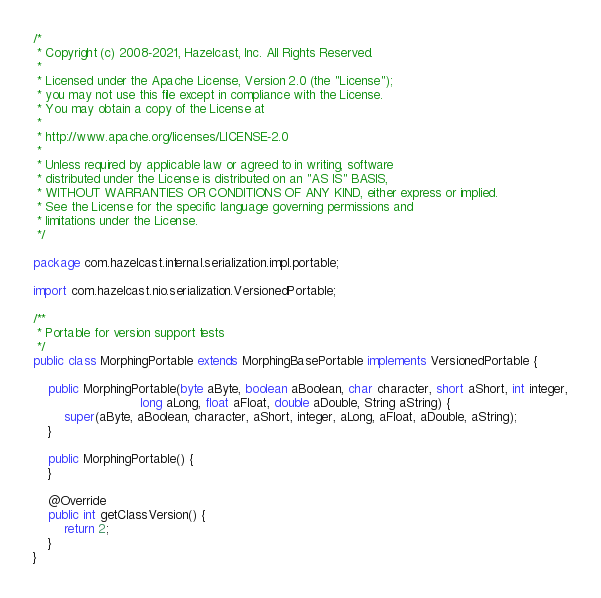<code> <loc_0><loc_0><loc_500><loc_500><_Java_>/*
 * Copyright (c) 2008-2021, Hazelcast, Inc. All Rights Reserved.
 *
 * Licensed under the Apache License, Version 2.0 (the "License");
 * you may not use this file except in compliance with the License.
 * You may obtain a copy of the License at
 *
 * http://www.apache.org/licenses/LICENSE-2.0
 *
 * Unless required by applicable law or agreed to in writing, software
 * distributed under the License is distributed on an "AS IS" BASIS,
 * WITHOUT WARRANTIES OR CONDITIONS OF ANY KIND, either express or implied.
 * See the License for the specific language governing permissions and
 * limitations under the License.
 */

package com.hazelcast.internal.serialization.impl.portable;

import com.hazelcast.nio.serialization.VersionedPortable;

/**
 * Portable for version support tests
 */
public class MorphingPortable extends MorphingBasePortable implements VersionedPortable {

    public MorphingPortable(byte aByte, boolean aBoolean, char character, short aShort, int integer,
                            long aLong, float aFloat, double aDouble, String aString) {
        super(aByte, aBoolean, character, aShort, integer, aLong, aFloat, aDouble, aString);
    }

    public MorphingPortable() {
    }

    @Override
    public int getClassVersion() {
        return 2;
    }
}
</code> 